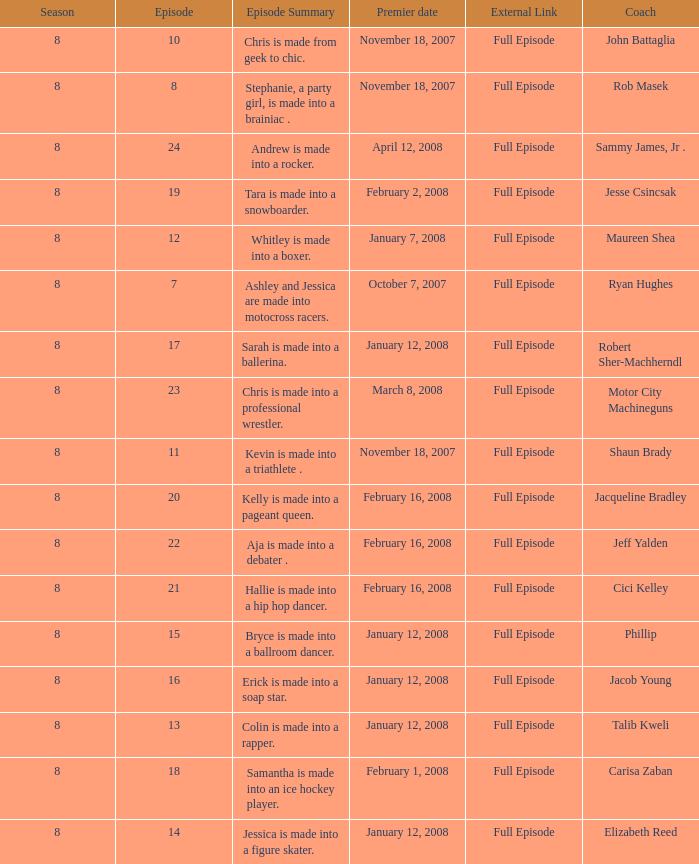Who was the coach for episode 15? Phillip. 